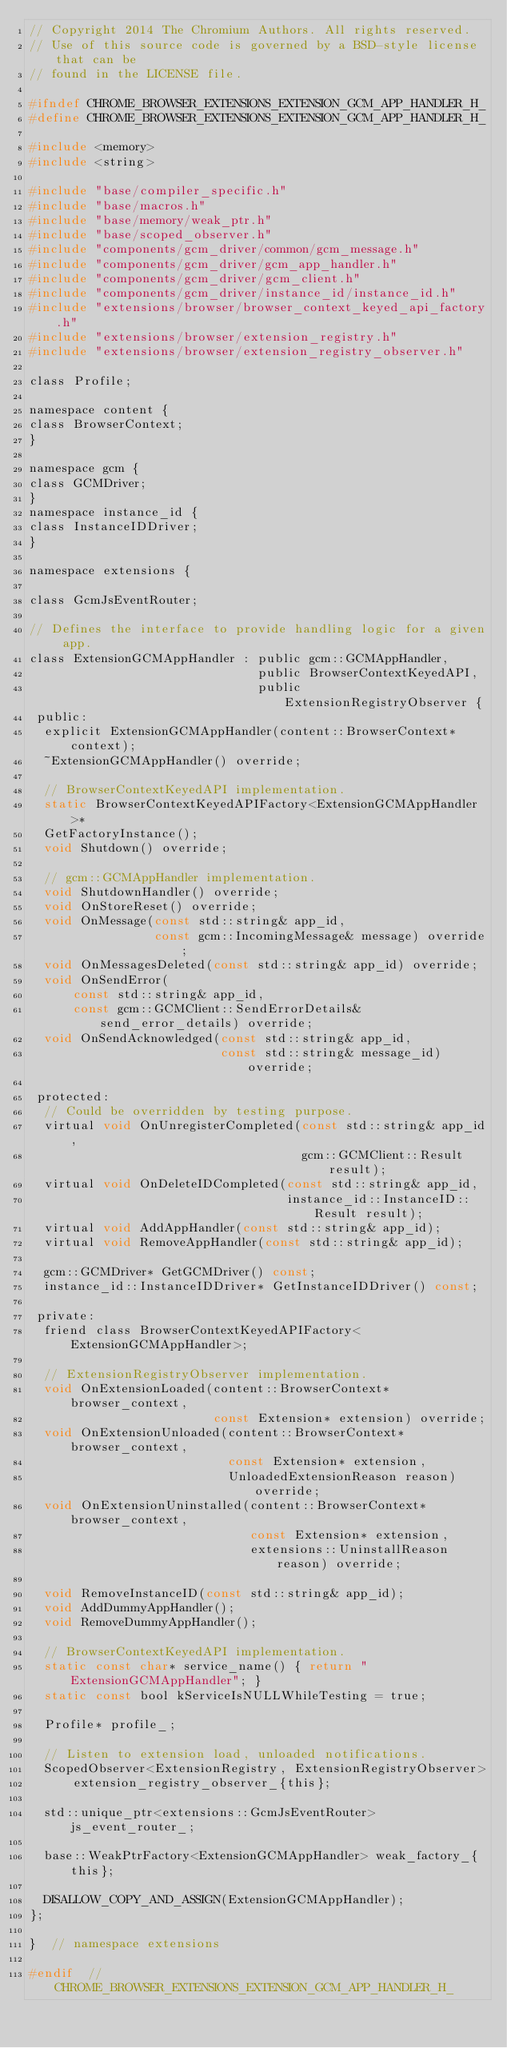Convert code to text. <code><loc_0><loc_0><loc_500><loc_500><_C_>// Copyright 2014 The Chromium Authors. All rights reserved.
// Use of this source code is governed by a BSD-style license that can be
// found in the LICENSE file.

#ifndef CHROME_BROWSER_EXTENSIONS_EXTENSION_GCM_APP_HANDLER_H_
#define CHROME_BROWSER_EXTENSIONS_EXTENSION_GCM_APP_HANDLER_H_

#include <memory>
#include <string>

#include "base/compiler_specific.h"
#include "base/macros.h"
#include "base/memory/weak_ptr.h"
#include "base/scoped_observer.h"
#include "components/gcm_driver/common/gcm_message.h"
#include "components/gcm_driver/gcm_app_handler.h"
#include "components/gcm_driver/gcm_client.h"
#include "components/gcm_driver/instance_id/instance_id.h"
#include "extensions/browser/browser_context_keyed_api_factory.h"
#include "extensions/browser/extension_registry.h"
#include "extensions/browser/extension_registry_observer.h"

class Profile;

namespace content {
class BrowserContext;
}

namespace gcm {
class GCMDriver;
}
namespace instance_id {
class InstanceIDDriver;
}

namespace extensions {

class GcmJsEventRouter;

// Defines the interface to provide handling logic for a given app.
class ExtensionGCMAppHandler : public gcm::GCMAppHandler,
                               public BrowserContextKeyedAPI,
                               public ExtensionRegistryObserver {
 public:
  explicit ExtensionGCMAppHandler(content::BrowserContext* context);
  ~ExtensionGCMAppHandler() override;

  // BrowserContextKeyedAPI implementation.
  static BrowserContextKeyedAPIFactory<ExtensionGCMAppHandler>*
  GetFactoryInstance();
  void Shutdown() override;

  // gcm::GCMAppHandler implementation.
  void ShutdownHandler() override;
  void OnStoreReset() override;
  void OnMessage(const std::string& app_id,
                 const gcm::IncomingMessage& message) override;
  void OnMessagesDeleted(const std::string& app_id) override;
  void OnSendError(
      const std::string& app_id,
      const gcm::GCMClient::SendErrorDetails& send_error_details) override;
  void OnSendAcknowledged(const std::string& app_id,
                          const std::string& message_id) override;

 protected:
  // Could be overridden by testing purpose.
  virtual void OnUnregisterCompleted(const std::string& app_id,
                                     gcm::GCMClient::Result result);
  virtual void OnDeleteIDCompleted(const std::string& app_id,
                                   instance_id::InstanceID::Result result);
  virtual void AddAppHandler(const std::string& app_id);
  virtual void RemoveAppHandler(const std::string& app_id);

  gcm::GCMDriver* GetGCMDriver() const;
  instance_id::InstanceIDDriver* GetInstanceIDDriver() const;

 private:
  friend class BrowserContextKeyedAPIFactory<ExtensionGCMAppHandler>;

  // ExtensionRegistryObserver implementation.
  void OnExtensionLoaded(content::BrowserContext* browser_context,
                         const Extension* extension) override;
  void OnExtensionUnloaded(content::BrowserContext* browser_context,
                           const Extension* extension,
                           UnloadedExtensionReason reason) override;
  void OnExtensionUninstalled(content::BrowserContext* browser_context,
                              const Extension* extension,
                              extensions::UninstallReason reason) override;

  void RemoveInstanceID(const std::string& app_id);
  void AddDummyAppHandler();
  void RemoveDummyAppHandler();

  // BrowserContextKeyedAPI implementation.
  static const char* service_name() { return "ExtensionGCMAppHandler"; }
  static const bool kServiceIsNULLWhileTesting = true;

  Profile* profile_;

  // Listen to extension load, unloaded notifications.
  ScopedObserver<ExtensionRegistry, ExtensionRegistryObserver>
      extension_registry_observer_{this};

  std::unique_ptr<extensions::GcmJsEventRouter> js_event_router_;

  base::WeakPtrFactory<ExtensionGCMAppHandler> weak_factory_{this};

  DISALLOW_COPY_AND_ASSIGN(ExtensionGCMAppHandler);
};

}  // namespace extensions

#endif  // CHROME_BROWSER_EXTENSIONS_EXTENSION_GCM_APP_HANDLER_H_
</code> 